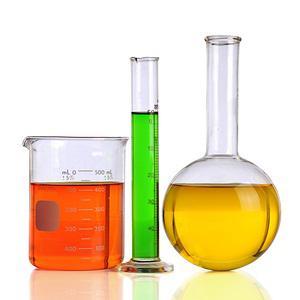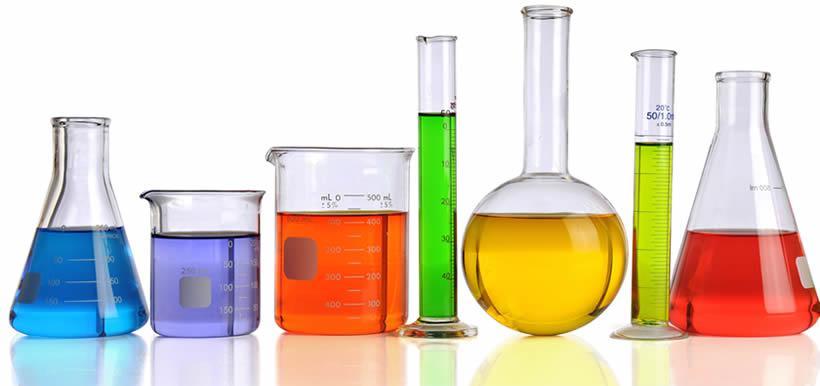The first image is the image on the left, the second image is the image on the right. For the images shown, is this caption "In the image on the right, the container furthest to the left contains a blue liquid." true? Answer yes or no. Yes. The first image is the image on the left, the second image is the image on the right. For the images shown, is this caption "One image shows exactly three containers of different colored liquids in a level row with no overlap, and one of the bottles has a round bottom and tall slender neck." true? Answer yes or no. Yes. 